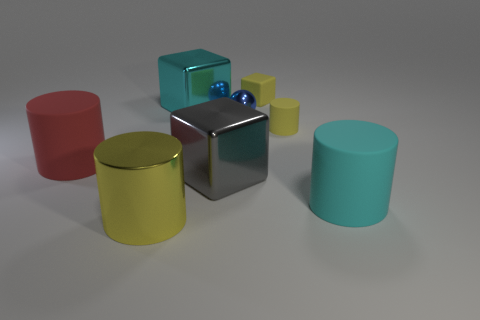Subtract 1 cylinders. How many cylinders are left? 3 Subtract all yellow cylinders. Subtract all red cubes. How many cylinders are left? 2 Add 2 rubber spheres. How many objects exist? 10 Subtract all blocks. How many objects are left? 5 Add 8 yellow matte blocks. How many yellow matte blocks are left? 9 Add 7 large blue rubber things. How many large blue rubber things exist? 7 Subtract 1 cyan blocks. How many objects are left? 7 Subtract all red rubber things. Subtract all small blue balls. How many objects are left? 6 